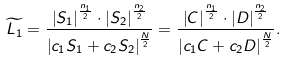<formula> <loc_0><loc_0><loc_500><loc_500>\widetilde { L _ { 1 } } = \frac { \left | S _ { 1 } \right | ^ { \frac { n _ { 1 } } { 2 } } \cdot \left | S _ { 2 } \right | ^ { \frac { n _ { 2 } } { 2 } } } { \left | c _ { 1 } S _ { 1 } + c _ { 2 } S _ { 2 } \right | ^ { \frac { N } { 2 } } } = \frac { \left | C \right | ^ { \frac { n _ { 1 } } { 2 } } \cdot \left | D \right | ^ { \frac { n _ { 2 } } { 2 } } } { \left | c _ { 1 } C + c _ { 2 } D \right | ^ { \frac { N } { 2 } } } .</formula> 